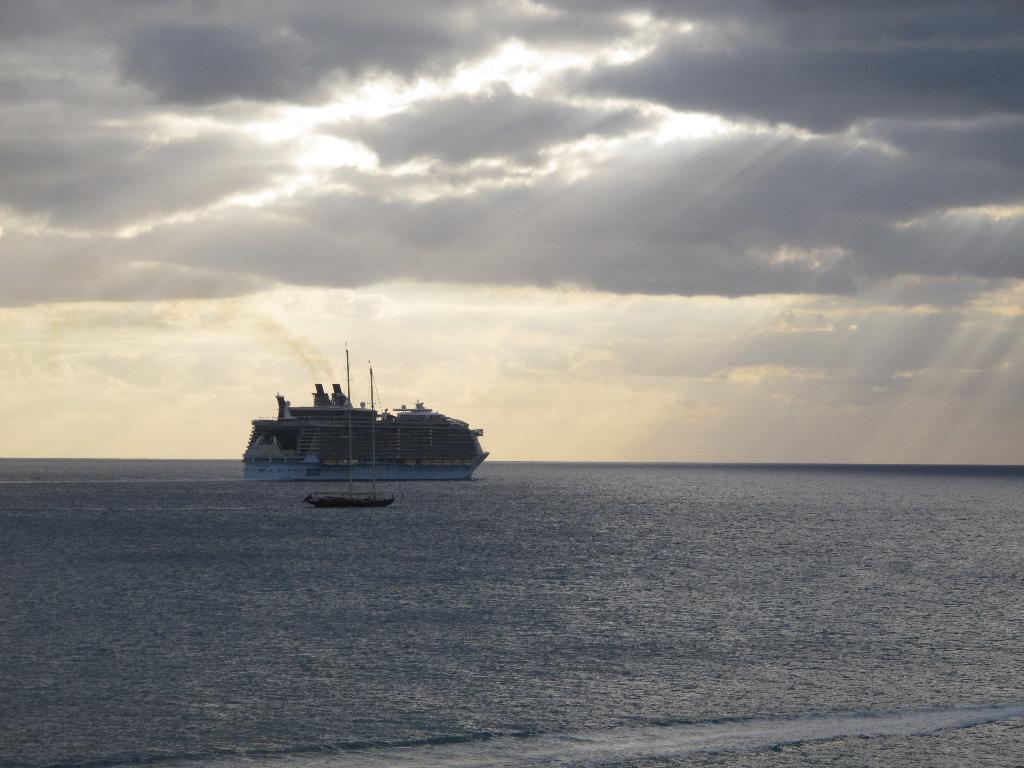How would you summarize this image in a sentence or two? In this image there is a ship and a boat are sailing on the surface of the water. Top of the image there is sky, having clouds. 